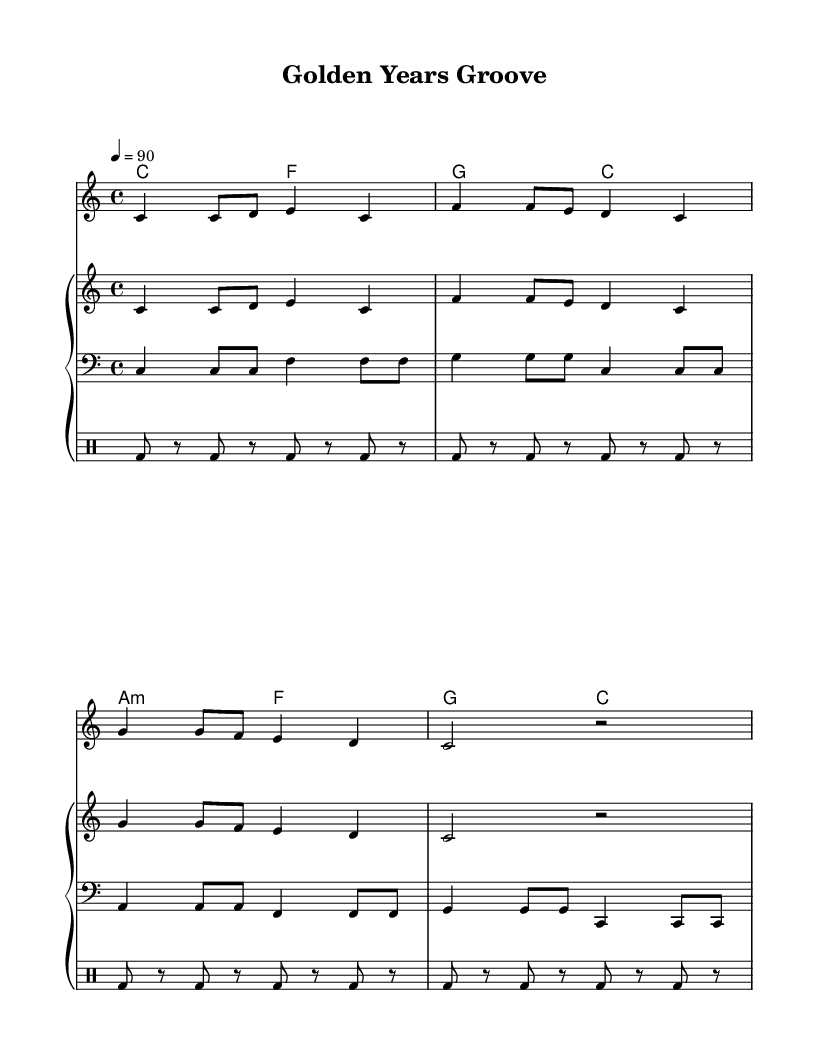What is the key signature of this music? The key signature is C major, which has no sharps or flats.
Answer: C major What is the time signature of the piece? The time signature is indicated as 4/4, meaning there are four beats in each measure.
Answer: 4/4 What is the tempo marking in the score? The tempo marking is indicated as 4 = 90, meaning a quarter note gets 90 beats per minute.
Answer: 90 What is the significance of the lyrics in this rap? The lyrics emphasize living fully in the golden years, expressing wisdom and enjoyment, which is encouraging for seniors.
Answer: Inspiration What is the instrument arrangement in the score? The music is arranged for piano with separate upper and lower staves, a bass line, and a drum pattern incorporated.
Answer: Piano, Bass, Drums How many measures are in the melody section? The melody section consists of four measures, which can be counted from the notation.
Answer: Four measures Which chord appears most frequently in the chord progression? The chord 'C' appears most frequently and is used in multiple sections of the progression.
Answer: C 